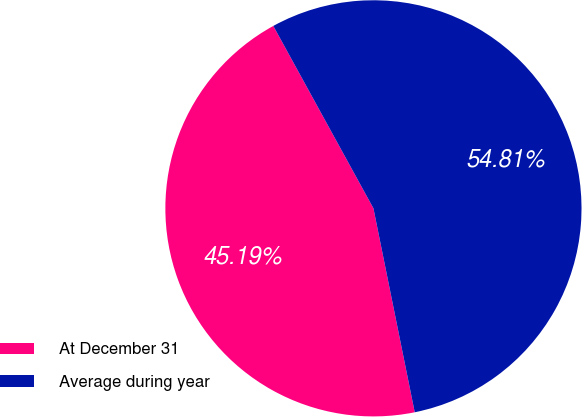<chart> <loc_0><loc_0><loc_500><loc_500><pie_chart><fcel>At December 31<fcel>Average during year<nl><fcel>45.19%<fcel>54.81%<nl></chart> 